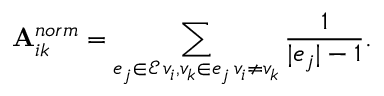Convert formula to latex. <formula><loc_0><loc_0><loc_500><loc_500>A _ { i k } ^ { n o r m } = \sum _ { \substack { e _ { j } \in \mathcal { E } \, v _ { i } , v _ { k } \in e _ { j } \, v _ { i } \neq v _ { k } } } \frac { 1 } { | e _ { j } | - 1 } .</formula> 